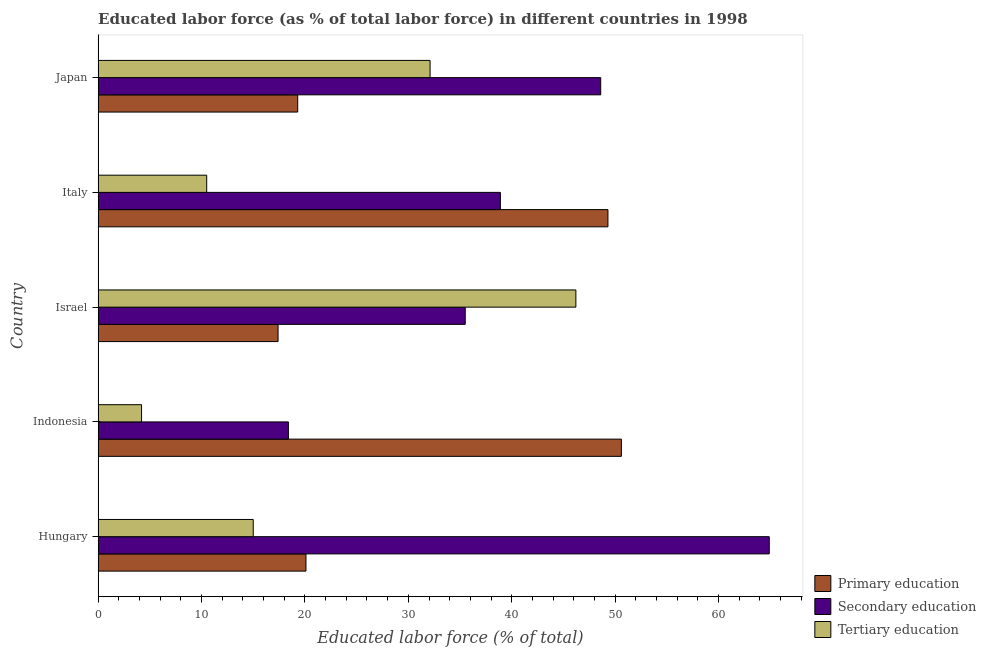Are the number of bars on each tick of the Y-axis equal?
Your answer should be very brief. Yes. How many bars are there on the 2nd tick from the bottom?
Provide a succinct answer. 3. In how many cases, is the number of bars for a given country not equal to the number of legend labels?
Ensure brevity in your answer.  0. What is the percentage of labor force who received secondary education in Indonesia?
Make the answer very short. 18.4. Across all countries, what is the maximum percentage of labor force who received tertiary education?
Your response must be concise. 46.2. Across all countries, what is the minimum percentage of labor force who received tertiary education?
Offer a terse response. 4.2. In which country was the percentage of labor force who received secondary education maximum?
Your answer should be compact. Hungary. In which country was the percentage of labor force who received secondary education minimum?
Your answer should be compact. Indonesia. What is the total percentage of labor force who received tertiary education in the graph?
Provide a succinct answer. 108. What is the difference between the percentage of labor force who received secondary education in Japan and the percentage of labor force who received primary education in Israel?
Offer a terse response. 31.2. What is the average percentage of labor force who received primary education per country?
Make the answer very short. 31.34. What is the difference between the percentage of labor force who received secondary education and percentage of labor force who received primary education in Indonesia?
Ensure brevity in your answer.  -32.2. In how many countries, is the percentage of labor force who received primary education greater than 16 %?
Your response must be concise. 5. What is the ratio of the percentage of labor force who received secondary education in Indonesia to that in Italy?
Give a very brief answer. 0.47. Is the percentage of labor force who received secondary education in Indonesia less than that in Italy?
Offer a terse response. Yes. Is the difference between the percentage of labor force who received tertiary education in Hungary and Japan greater than the difference between the percentage of labor force who received primary education in Hungary and Japan?
Offer a very short reply. No. What is the difference between the highest and the second highest percentage of labor force who received primary education?
Give a very brief answer. 1.3. What is the difference between the highest and the lowest percentage of labor force who received tertiary education?
Provide a succinct answer. 42. Is the sum of the percentage of labor force who received tertiary education in Hungary and Italy greater than the maximum percentage of labor force who received secondary education across all countries?
Your response must be concise. No. What does the 1st bar from the top in Indonesia represents?
Your answer should be compact. Tertiary education. What does the 3rd bar from the bottom in Italy represents?
Keep it short and to the point. Tertiary education. Is it the case that in every country, the sum of the percentage of labor force who received primary education and percentage of labor force who received secondary education is greater than the percentage of labor force who received tertiary education?
Your response must be concise. Yes. Are all the bars in the graph horizontal?
Provide a short and direct response. Yes. Are the values on the major ticks of X-axis written in scientific E-notation?
Offer a terse response. No. Does the graph contain grids?
Give a very brief answer. No. What is the title of the graph?
Provide a succinct answer. Educated labor force (as % of total labor force) in different countries in 1998. What is the label or title of the X-axis?
Make the answer very short. Educated labor force (% of total). What is the label or title of the Y-axis?
Your response must be concise. Country. What is the Educated labor force (% of total) of Primary education in Hungary?
Offer a very short reply. 20.1. What is the Educated labor force (% of total) of Secondary education in Hungary?
Provide a short and direct response. 64.9. What is the Educated labor force (% of total) of Tertiary education in Hungary?
Provide a short and direct response. 15. What is the Educated labor force (% of total) of Primary education in Indonesia?
Make the answer very short. 50.6. What is the Educated labor force (% of total) in Secondary education in Indonesia?
Ensure brevity in your answer.  18.4. What is the Educated labor force (% of total) of Tertiary education in Indonesia?
Give a very brief answer. 4.2. What is the Educated labor force (% of total) of Primary education in Israel?
Your response must be concise. 17.4. What is the Educated labor force (% of total) in Secondary education in Israel?
Give a very brief answer. 35.5. What is the Educated labor force (% of total) in Tertiary education in Israel?
Offer a very short reply. 46.2. What is the Educated labor force (% of total) in Primary education in Italy?
Your answer should be very brief. 49.3. What is the Educated labor force (% of total) in Secondary education in Italy?
Provide a succinct answer. 38.9. What is the Educated labor force (% of total) of Tertiary education in Italy?
Ensure brevity in your answer.  10.5. What is the Educated labor force (% of total) of Primary education in Japan?
Keep it short and to the point. 19.3. What is the Educated labor force (% of total) of Secondary education in Japan?
Your answer should be compact. 48.6. What is the Educated labor force (% of total) in Tertiary education in Japan?
Ensure brevity in your answer.  32.1. Across all countries, what is the maximum Educated labor force (% of total) in Primary education?
Offer a very short reply. 50.6. Across all countries, what is the maximum Educated labor force (% of total) of Secondary education?
Offer a very short reply. 64.9. Across all countries, what is the maximum Educated labor force (% of total) in Tertiary education?
Offer a very short reply. 46.2. Across all countries, what is the minimum Educated labor force (% of total) of Primary education?
Provide a succinct answer. 17.4. Across all countries, what is the minimum Educated labor force (% of total) in Secondary education?
Offer a very short reply. 18.4. Across all countries, what is the minimum Educated labor force (% of total) of Tertiary education?
Make the answer very short. 4.2. What is the total Educated labor force (% of total) in Primary education in the graph?
Provide a succinct answer. 156.7. What is the total Educated labor force (% of total) of Secondary education in the graph?
Your answer should be compact. 206.3. What is the total Educated labor force (% of total) in Tertiary education in the graph?
Provide a succinct answer. 108. What is the difference between the Educated labor force (% of total) in Primary education in Hungary and that in Indonesia?
Your answer should be very brief. -30.5. What is the difference between the Educated labor force (% of total) of Secondary education in Hungary and that in Indonesia?
Provide a succinct answer. 46.5. What is the difference between the Educated labor force (% of total) of Secondary education in Hungary and that in Israel?
Keep it short and to the point. 29.4. What is the difference between the Educated labor force (% of total) of Tertiary education in Hungary and that in Israel?
Your answer should be compact. -31.2. What is the difference between the Educated labor force (% of total) in Primary education in Hungary and that in Italy?
Provide a succinct answer. -29.2. What is the difference between the Educated labor force (% of total) of Primary education in Hungary and that in Japan?
Keep it short and to the point. 0.8. What is the difference between the Educated labor force (% of total) in Secondary education in Hungary and that in Japan?
Keep it short and to the point. 16.3. What is the difference between the Educated labor force (% of total) of Tertiary education in Hungary and that in Japan?
Offer a terse response. -17.1. What is the difference between the Educated labor force (% of total) of Primary education in Indonesia and that in Israel?
Your answer should be compact. 33.2. What is the difference between the Educated labor force (% of total) of Secondary education in Indonesia and that in Israel?
Provide a short and direct response. -17.1. What is the difference between the Educated labor force (% of total) of Tertiary education in Indonesia and that in Israel?
Your response must be concise. -42. What is the difference between the Educated labor force (% of total) in Secondary education in Indonesia and that in Italy?
Your answer should be very brief. -20.5. What is the difference between the Educated labor force (% of total) of Tertiary education in Indonesia and that in Italy?
Make the answer very short. -6.3. What is the difference between the Educated labor force (% of total) in Primary education in Indonesia and that in Japan?
Your answer should be very brief. 31.3. What is the difference between the Educated labor force (% of total) in Secondary education in Indonesia and that in Japan?
Offer a terse response. -30.2. What is the difference between the Educated labor force (% of total) of Tertiary education in Indonesia and that in Japan?
Offer a very short reply. -27.9. What is the difference between the Educated labor force (% of total) in Primary education in Israel and that in Italy?
Your answer should be very brief. -31.9. What is the difference between the Educated labor force (% of total) in Tertiary education in Israel and that in Italy?
Keep it short and to the point. 35.7. What is the difference between the Educated labor force (% of total) of Primary education in Italy and that in Japan?
Keep it short and to the point. 30. What is the difference between the Educated labor force (% of total) of Secondary education in Italy and that in Japan?
Your answer should be very brief. -9.7. What is the difference between the Educated labor force (% of total) in Tertiary education in Italy and that in Japan?
Your answer should be very brief. -21.6. What is the difference between the Educated labor force (% of total) of Primary education in Hungary and the Educated labor force (% of total) of Secondary education in Indonesia?
Provide a short and direct response. 1.7. What is the difference between the Educated labor force (% of total) of Secondary education in Hungary and the Educated labor force (% of total) of Tertiary education in Indonesia?
Offer a very short reply. 60.7. What is the difference between the Educated labor force (% of total) in Primary education in Hungary and the Educated labor force (% of total) in Secondary education in Israel?
Make the answer very short. -15.4. What is the difference between the Educated labor force (% of total) of Primary education in Hungary and the Educated labor force (% of total) of Tertiary education in Israel?
Give a very brief answer. -26.1. What is the difference between the Educated labor force (% of total) of Primary education in Hungary and the Educated labor force (% of total) of Secondary education in Italy?
Your answer should be compact. -18.8. What is the difference between the Educated labor force (% of total) in Primary education in Hungary and the Educated labor force (% of total) in Tertiary education in Italy?
Keep it short and to the point. 9.6. What is the difference between the Educated labor force (% of total) of Secondary education in Hungary and the Educated labor force (% of total) of Tertiary education in Italy?
Offer a terse response. 54.4. What is the difference between the Educated labor force (% of total) in Primary education in Hungary and the Educated labor force (% of total) in Secondary education in Japan?
Make the answer very short. -28.5. What is the difference between the Educated labor force (% of total) of Secondary education in Hungary and the Educated labor force (% of total) of Tertiary education in Japan?
Your answer should be compact. 32.8. What is the difference between the Educated labor force (% of total) of Primary education in Indonesia and the Educated labor force (% of total) of Tertiary education in Israel?
Your answer should be compact. 4.4. What is the difference between the Educated labor force (% of total) in Secondary education in Indonesia and the Educated labor force (% of total) in Tertiary education in Israel?
Make the answer very short. -27.8. What is the difference between the Educated labor force (% of total) in Primary education in Indonesia and the Educated labor force (% of total) in Secondary education in Italy?
Provide a short and direct response. 11.7. What is the difference between the Educated labor force (% of total) in Primary education in Indonesia and the Educated labor force (% of total) in Tertiary education in Italy?
Your answer should be very brief. 40.1. What is the difference between the Educated labor force (% of total) of Primary education in Indonesia and the Educated labor force (% of total) of Secondary education in Japan?
Your answer should be very brief. 2. What is the difference between the Educated labor force (% of total) of Secondary education in Indonesia and the Educated labor force (% of total) of Tertiary education in Japan?
Keep it short and to the point. -13.7. What is the difference between the Educated labor force (% of total) in Primary education in Israel and the Educated labor force (% of total) in Secondary education in Italy?
Keep it short and to the point. -21.5. What is the difference between the Educated labor force (% of total) of Primary education in Israel and the Educated labor force (% of total) of Tertiary education in Italy?
Make the answer very short. 6.9. What is the difference between the Educated labor force (% of total) in Secondary education in Israel and the Educated labor force (% of total) in Tertiary education in Italy?
Ensure brevity in your answer.  25. What is the difference between the Educated labor force (% of total) in Primary education in Israel and the Educated labor force (% of total) in Secondary education in Japan?
Provide a succinct answer. -31.2. What is the difference between the Educated labor force (% of total) in Primary education in Israel and the Educated labor force (% of total) in Tertiary education in Japan?
Provide a short and direct response. -14.7. What is the difference between the Educated labor force (% of total) in Secondary education in Israel and the Educated labor force (% of total) in Tertiary education in Japan?
Provide a succinct answer. 3.4. What is the difference between the Educated labor force (% of total) of Primary education in Italy and the Educated labor force (% of total) of Tertiary education in Japan?
Your response must be concise. 17.2. What is the average Educated labor force (% of total) of Primary education per country?
Make the answer very short. 31.34. What is the average Educated labor force (% of total) of Secondary education per country?
Give a very brief answer. 41.26. What is the average Educated labor force (% of total) of Tertiary education per country?
Give a very brief answer. 21.6. What is the difference between the Educated labor force (% of total) of Primary education and Educated labor force (% of total) of Secondary education in Hungary?
Offer a terse response. -44.8. What is the difference between the Educated labor force (% of total) in Primary education and Educated labor force (% of total) in Tertiary education in Hungary?
Your response must be concise. 5.1. What is the difference between the Educated labor force (% of total) of Secondary education and Educated labor force (% of total) of Tertiary education in Hungary?
Your response must be concise. 49.9. What is the difference between the Educated labor force (% of total) in Primary education and Educated labor force (% of total) in Secondary education in Indonesia?
Offer a terse response. 32.2. What is the difference between the Educated labor force (% of total) in Primary education and Educated labor force (% of total) in Tertiary education in Indonesia?
Your answer should be very brief. 46.4. What is the difference between the Educated labor force (% of total) of Secondary education and Educated labor force (% of total) of Tertiary education in Indonesia?
Your response must be concise. 14.2. What is the difference between the Educated labor force (% of total) of Primary education and Educated labor force (% of total) of Secondary education in Israel?
Provide a succinct answer. -18.1. What is the difference between the Educated labor force (% of total) of Primary education and Educated labor force (% of total) of Tertiary education in Israel?
Offer a very short reply. -28.8. What is the difference between the Educated labor force (% of total) in Primary education and Educated labor force (% of total) in Tertiary education in Italy?
Make the answer very short. 38.8. What is the difference between the Educated labor force (% of total) in Secondary education and Educated labor force (% of total) in Tertiary education in Italy?
Provide a succinct answer. 28.4. What is the difference between the Educated labor force (% of total) in Primary education and Educated labor force (% of total) in Secondary education in Japan?
Ensure brevity in your answer.  -29.3. What is the difference between the Educated labor force (% of total) of Primary education and Educated labor force (% of total) of Tertiary education in Japan?
Your response must be concise. -12.8. What is the ratio of the Educated labor force (% of total) of Primary education in Hungary to that in Indonesia?
Your response must be concise. 0.4. What is the ratio of the Educated labor force (% of total) of Secondary education in Hungary to that in Indonesia?
Give a very brief answer. 3.53. What is the ratio of the Educated labor force (% of total) of Tertiary education in Hungary to that in Indonesia?
Ensure brevity in your answer.  3.57. What is the ratio of the Educated labor force (% of total) in Primary education in Hungary to that in Israel?
Offer a very short reply. 1.16. What is the ratio of the Educated labor force (% of total) of Secondary education in Hungary to that in Israel?
Make the answer very short. 1.83. What is the ratio of the Educated labor force (% of total) of Tertiary education in Hungary to that in Israel?
Provide a succinct answer. 0.32. What is the ratio of the Educated labor force (% of total) of Primary education in Hungary to that in Italy?
Your response must be concise. 0.41. What is the ratio of the Educated labor force (% of total) of Secondary education in Hungary to that in Italy?
Keep it short and to the point. 1.67. What is the ratio of the Educated labor force (% of total) of Tertiary education in Hungary to that in Italy?
Your response must be concise. 1.43. What is the ratio of the Educated labor force (% of total) in Primary education in Hungary to that in Japan?
Offer a terse response. 1.04. What is the ratio of the Educated labor force (% of total) in Secondary education in Hungary to that in Japan?
Offer a very short reply. 1.34. What is the ratio of the Educated labor force (% of total) in Tertiary education in Hungary to that in Japan?
Your answer should be compact. 0.47. What is the ratio of the Educated labor force (% of total) of Primary education in Indonesia to that in Israel?
Your answer should be very brief. 2.91. What is the ratio of the Educated labor force (% of total) in Secondary education in Indonesia to that in Israel?
Your response must be concise. 0.52. What is the ratio of the Educated labor force (% of total) in Tertiary education in Indonesia to that in Israel?
Offer a terse response. 0.09. What is the ratio of the Educated labor force (% of total) of Primary education in Indonesia to that in Italy?
Provide a succinct answer. 1.03. What is the ratio of the Educated labor force (% of total) in Secondary education in Indonesia to that in Italy?
Your response must be concise. 0.47. What is the ratio of the Educated labor force (% of total) in Tertiary education in Indonesia to that in Italy?
Make the answer very short. 0.4. What is the ratio of the Educated labor force (% of total) of Primary education in Indonesia to that in Japan?
Offer a terse response. 2.62. What is the ratio of the Educated labor force (% of total) of Secondary education in Indonesia to that in Japan?
Give a very brief answer. 0.38. What is the ratio of the Educated labor force (% of total) in Tertiary education in Indonesia to that in Japan?
Give a very brief answer. 0.13. What is the ratio of the Educated labor force (% of total) in Primary education in Israel to that in Italy?
Your answer should be very brief. 0.35. What is the ratio of the Educated labor force (% of total) in Secondary education in Israel to that in Italy?
Keep it short and to the point. 0.91. What is the ratio of the Educated labor force (% of total) in Primary education in Israel to that in Japan?
Your response must be concise. 0.9. What is the ratio of the Educated labor force (% of total) in Secondary education in Israel to that in Japan?
Keep it short and to the point. 0.73. What is the ratio of the Educated labor force (% of total) in Tertiary education in Israel to that in Japan?
Your response must be concise. 1.44. What is the ratio of the Educated labor force (% of total) in Primary education in Italy to that in Japan?
Offer a terse response. 2.55. What is the ratio of the Educated labor force (% of total) in Secondary education in Italy to that in Japan?
Your response must be concise. 0.8. What is the ratio of the Educated labor force (% of total) in Tertiary education in Italy to that in Japan?
Your answer should be compact. 0.33. What is the difference between the highest and the lowest Educated labor force (% of total) of Primary education?
Your response must be concise. 33.2. What is the difference between the highest and the lowest Educated labor force (% of total) of Secondary education?
Your answer should be compact. 46.5. What is the difference between the highest and the lowest Educated labor force (% of total) in Tertiary education?
Offer a very short reply. 42. 